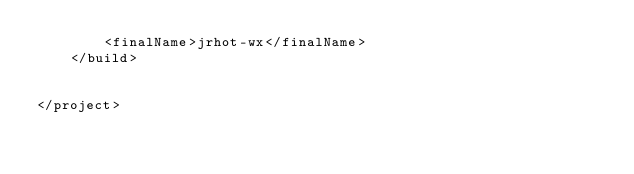Convert code to text. <code><loc_0><loc_0><loc_500><loc_500><_XML_>        <finalName>jrhot-wx</finalName>
    </build>


</project></code> 